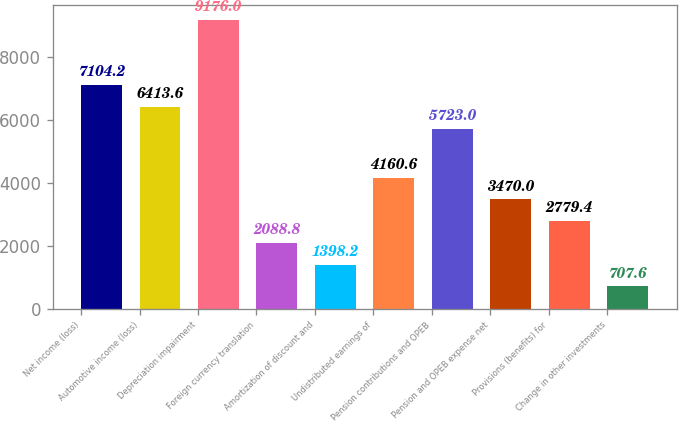Convert chart to OTSL. <chart><loc_0><loc_0><loc_500><loc_500><bar_chart><fcel>Net income (loss)<fcel>Automotive income (loss)<fcel>Depreciation impairment<fcel>Foreign currency translation<fcel>Amortization of discount and<fcel>Undistributed earnings of<fcel>Pension contributions and OPEB<fcel>Pension and OPEB expense net<fcel>Provisions (benefits) for<fcel>Change in other investments<nl><fcel>7104.2<fcel>6413.6<fcel>9176<fcel>2088.8<fcel>1398.2<fcel>4160.6<fcel>5723<fcel>3470<fcel>2779.4<fcel>707.6<nl></chart> 